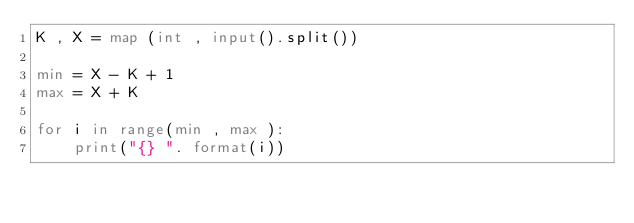<code> <loc_0><loc_0><loc_500><loc_500><_Python_>K , X = map (int , input().split())

min = X - K + 1
max = X + K 

for i in range(min , max ):
    print("{} ". format(i))</code> 